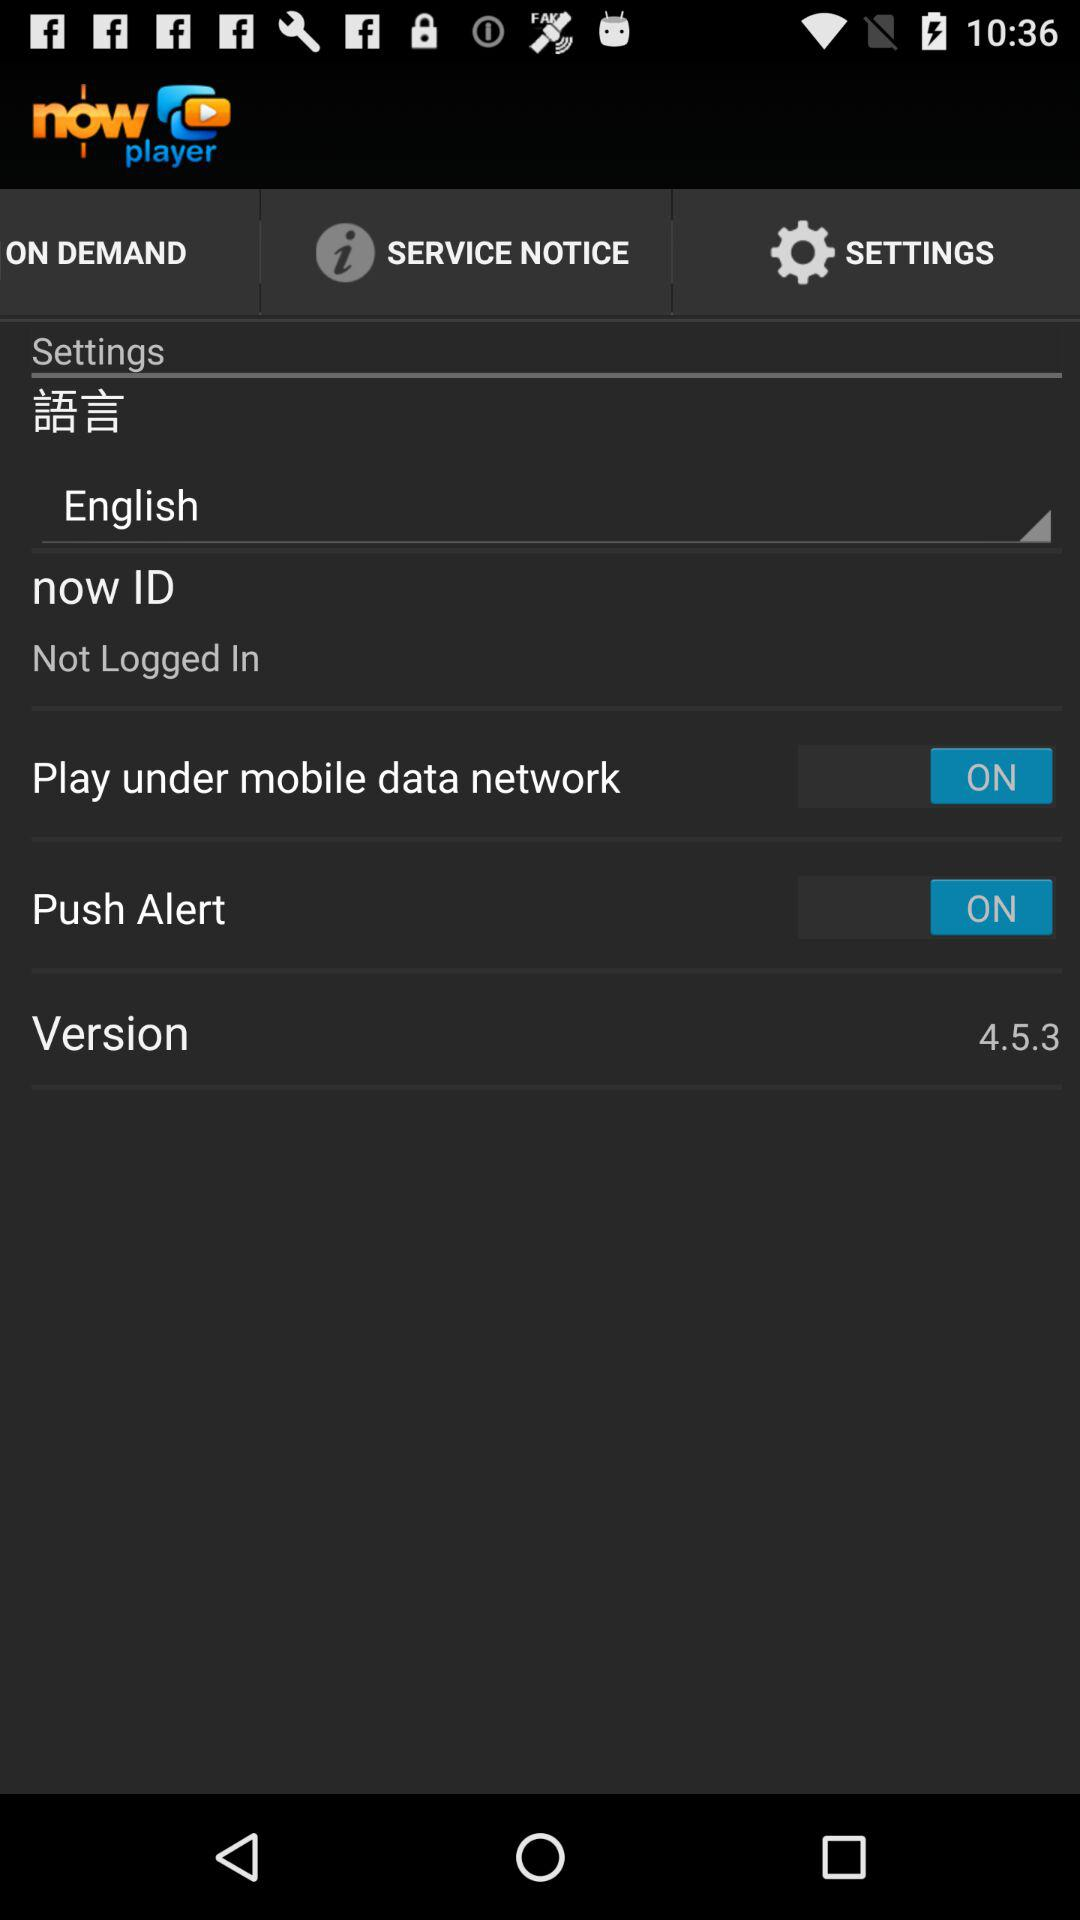What is the selected language? The selected language is English. 